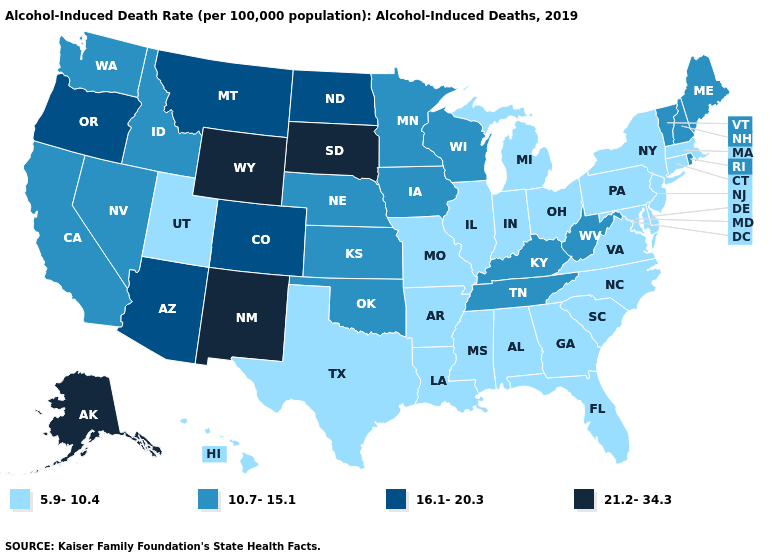What is the lowest value in the MidWest?
Write a very short answer. 5.9-10.4. What is the lowest value in the West?
Concise answer only. 5.9-10.4. Does Washington have the lowest value in the West?
Give a very brief answer. No. What is the value of New Hampshire?
Quick response, please. 10.7-15.1. What is the value of New Hampshire?
Quick response, please. 10.7-15.1. Name the states that have a value in the range 5.9-10.4?
Answer briefly. Alabama, Arkansas, Connecticut, Delaware, Florida, Georgia, Hawaii, Illinois, Indiana, Louisiana, Maryland, Massachusetts, Michigan, Mississippi, Missouri, New Jersey, New York, North Carolina, Ohio, Pennsylvania, South Carolina, Texas, Utah, Virginia. Name the states that have a value in the range 21.2-34.3?
Short answer required. Alaska, New Mexico, South Dakota, Wyoming. Does Alaska have the highest value in the West?
Answer briefly. Yes. What is the value of Washington?
Answer briefly. 10.7-15.1. Does the first symbol in the legend represent the smallest category?
Be succinct. Yes. What is the lowest value in the West?
Write a very short answer. 5.9-10.4. What is the highest value in the USA?
Give a very brief answer. 21.2-34.3. Is the legend a continuous bar?
Keep it brief. No. Among the states that border South Dakota , which have the lowest value?
Quick response, please. Iowa, Minnesota, Nebraska. 